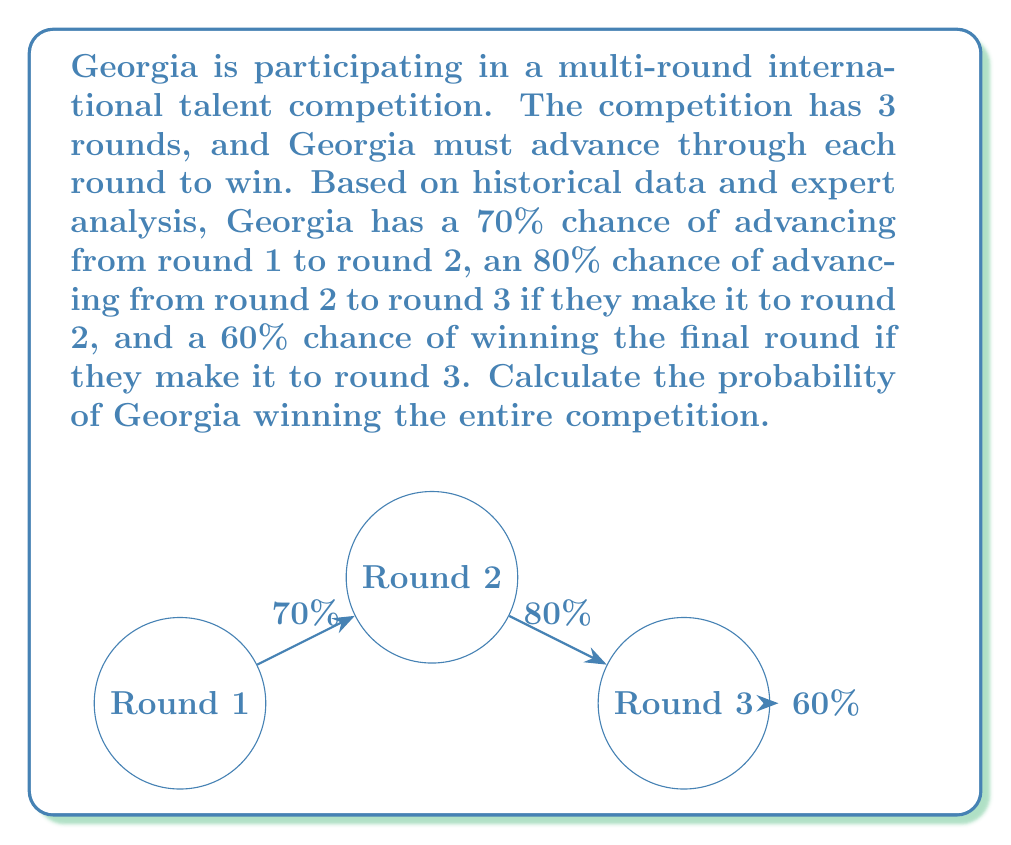Could you help me with this problem? To solve this problem, we need to use the multiplication rule of probability for independent events. The probability of Georgia winning the entire competition is the product of the probabilities of advancing through each round:

1) Let's define the events:
   $A$: Advancing from round 1 to round 2
   $B$: Advancing from round 2 to round 3
   $C$: Winning the final round

2) Given probabilities:
   $P(A) = 0.70$
   $P(B|A) = 0.80$ (probability of B given A has occurred)
   $P(C|B) = 0.60$ (probability of C given B has occurred)

3) The probability of winning the entire competition is:
   $P(\text{winning}) = P(A) \times P(B|A) \times P(C|B)$

4) Substituting the values:
   $P(\text{winning}) = 0.70 \times 0.80 \times 0.60$

5) Calculate:
   $P(\text{winning}) = 0.336$

6) Convert to percentage:
   $0.336 \times 100\% = 33.6\%$

Therefore, the probability of Georgia winning the entire competition is 33.6% or 0.336.
Answer: $33.6\%$ or $0.336$ 